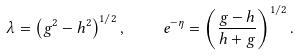<formula> <loc_0><loc_0><loc_500><loc_500>\lambda = \left ( g ^ { 2 } - h ^ { 2 } \right ) ^ { 1 / 2 } , \quad e ^ { - \eta } = \left ( \frac { g - h } { h + g } \right ) ^ { 1 / 2 } .</formula> 